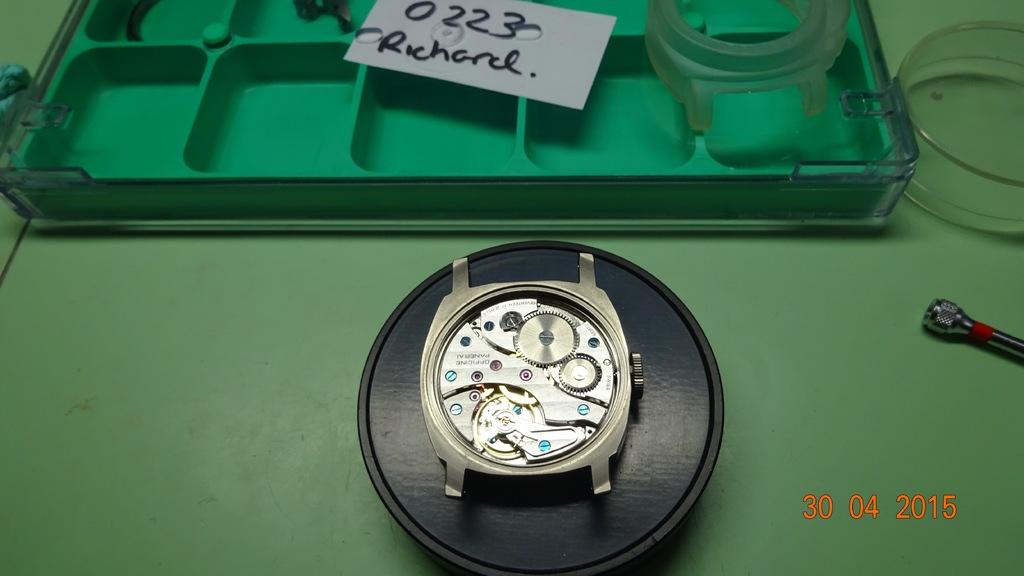<image>
Relay a brief, clear account of the picture shown. The insides of a watch below a tag reading 0223 Richard. 